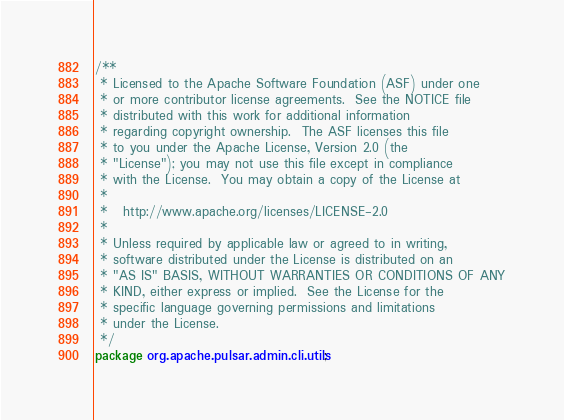Convert code to text. <code><loc_0><loc_0><loc_500><loc_500><_Java_>/**
 * Licensed to the Apache Software Foundation (ASF) under one
 * or more contributor license agreements.  See the NOTICE file
 * distributed with this work for additional information
 * regarding copyright ownership.  The ASF licenses this file
 * to you under the Apache License, Version 2.0 (the
 * "License"); you may not use this file except in compliance
 * with the License.  You may obtain a copy of the License at
 *
 *   http://www.apache.org/licenses/LICENSE-2.0
 *
 * Unless required by applicable law or agreed to in writing,
 * software distributed under the License is distributed on an
 * "AS IS" BASIS, WITHOUT WARRANTIES OR CONDITIONS OF ANY
 * KIND, either express or implied.  See the License for the
 * specific language governing permissions and limitations
 * under the License.
 */
package org.apache.pulsar.admin.cli.utils;
</code> 